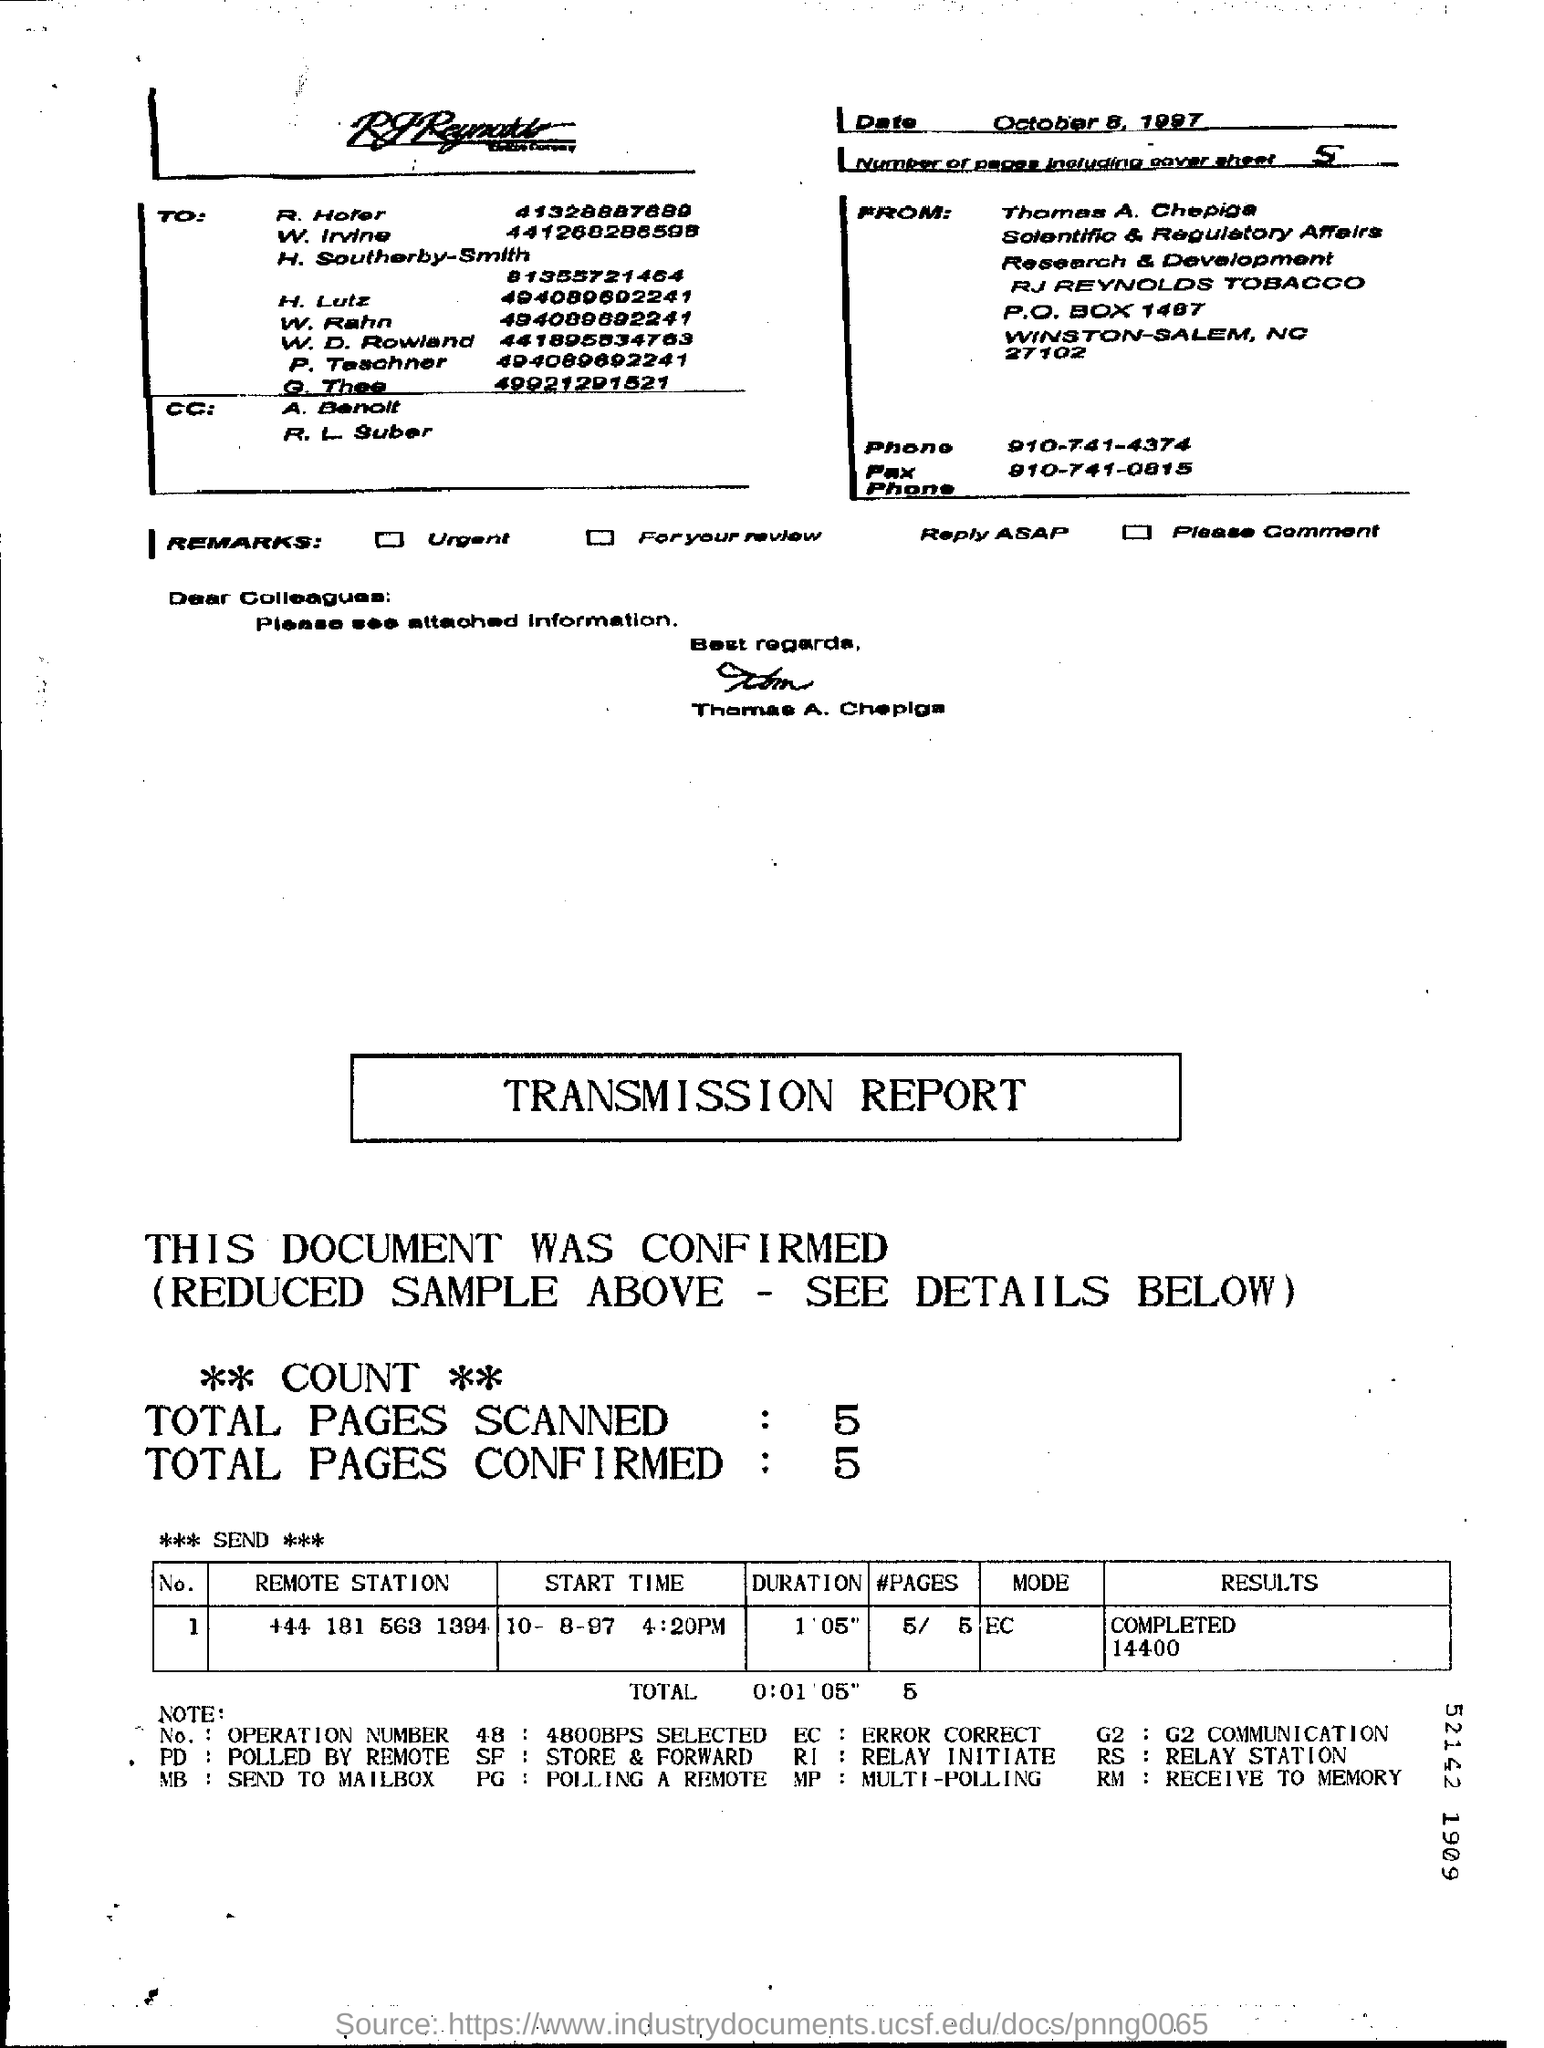What is the first name of the person who sent this?
Make the answer very short. Thomas. What is the number of pages in the fax including cover sheet?
Keep it short and to the point. 5. What is the Fax phone no of Thomas A. Chepiga?
Provide a short and direct response. 910-741-0815. Which Remote station belongs to Operation Number(No.) 1?
Give a very brief answer. +44 181 563 1394. What is the duration mentioned in the transmission report?
Provide a succinct answer. 1 ' 05". What is the mode given in the transmission report?
Provide a succinct answer. EC. 